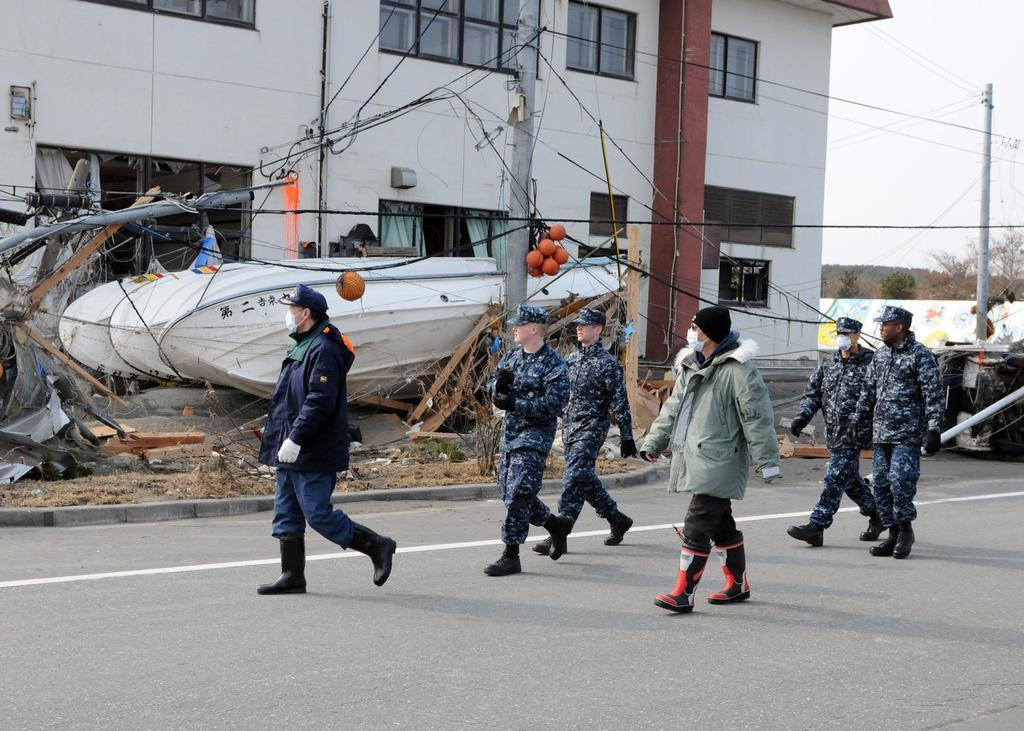What are the people in the image doing? The people in the image are walking on the road. What can be seen in the background of the image? There is a building and a pole with many wires in the background. What type of location is visible in the background? There is a scrap yard in the background. How many vans can be seen getting a haircut in the image? There are no vans or haircuts present in the image. What type of breath is visible coming from the people walking on the road? There is no visible breath in the image, as it is not cold enough to see people's breath. 